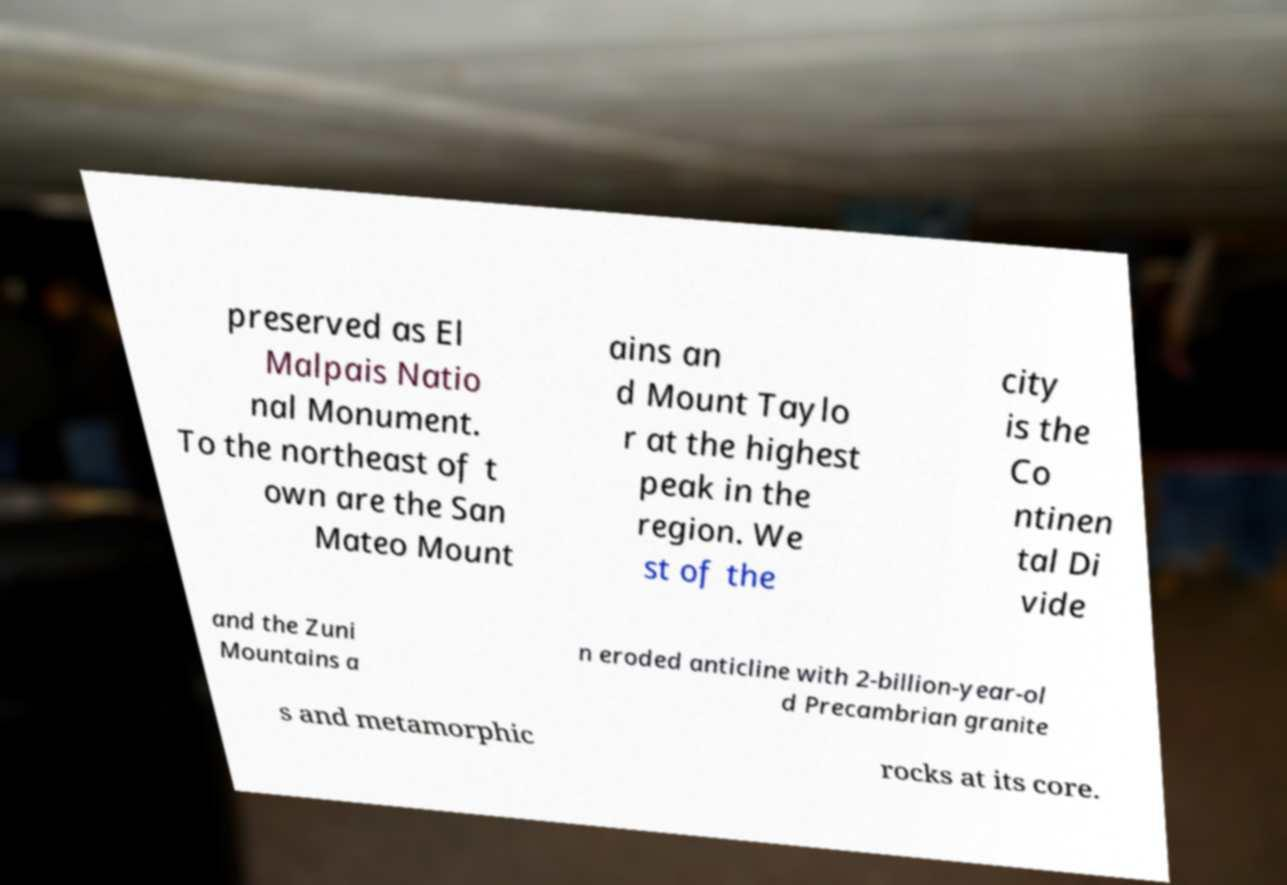For documentation purposes, I need the text within this image transcribed. Could you provide that? preserved as El Malpais Natio nal Monument. To the northeast of t own are the San Mateo Mount ains an d Mount Taylo r at the highest peak in the region. We st of the city is the Co ntinen tal Di vide and the Zuni Mountains a n eroded anticline with 2-billion-year-ol d Precambrian granite s and metamorphic rocks at its core. 